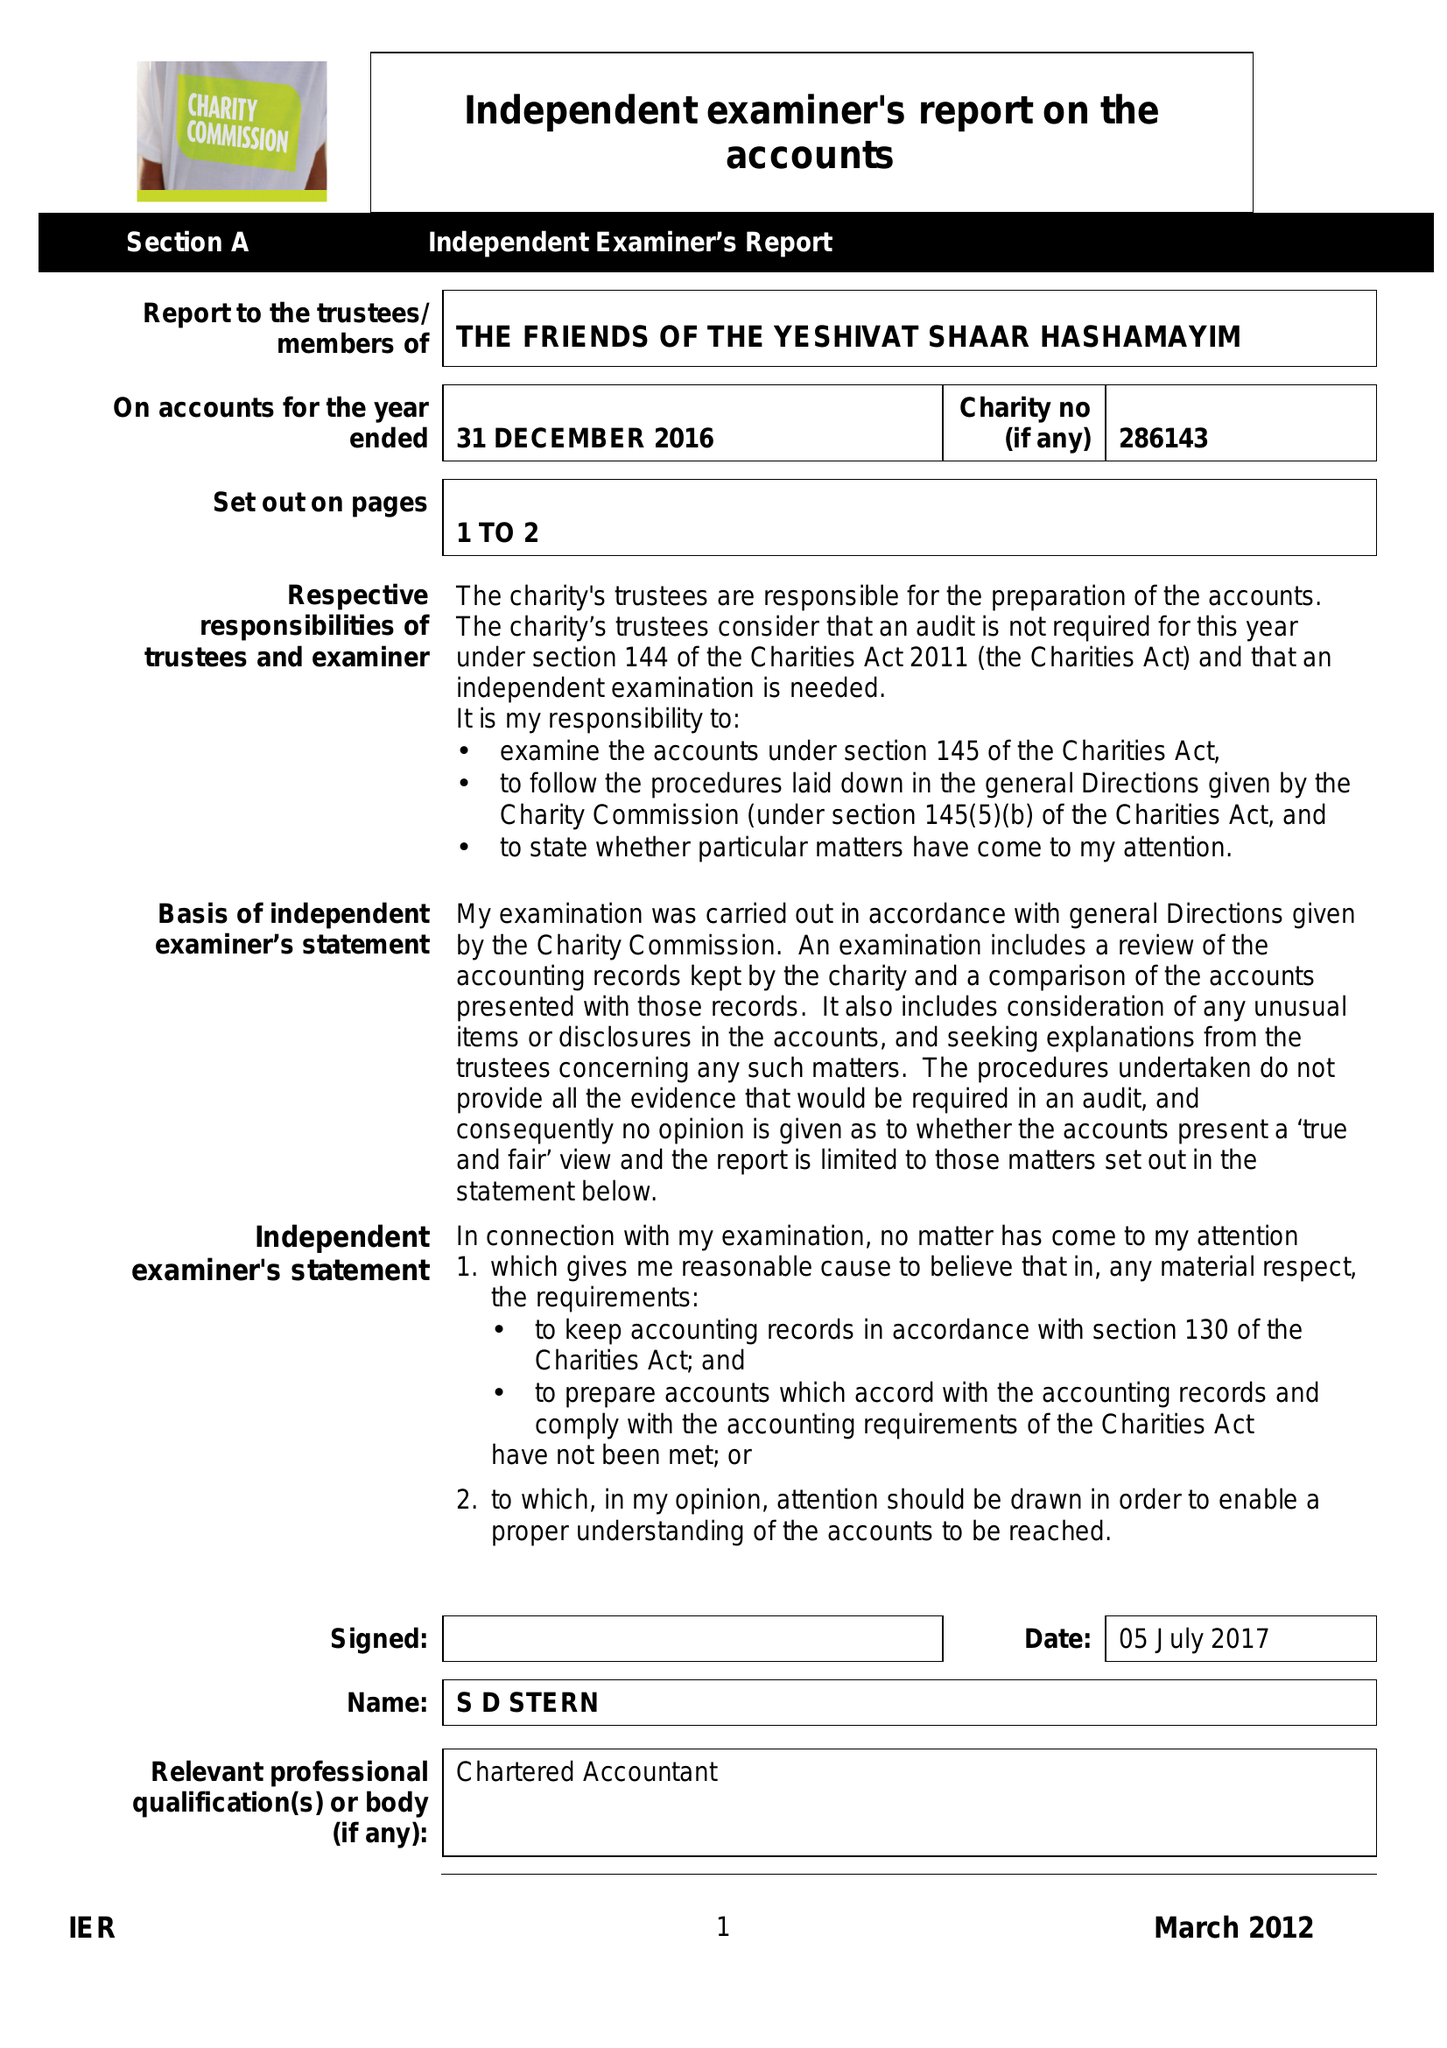What is the value for the spending_annually_in_british_pounds?
Answer the question using a single word or phrase. 52812.00 